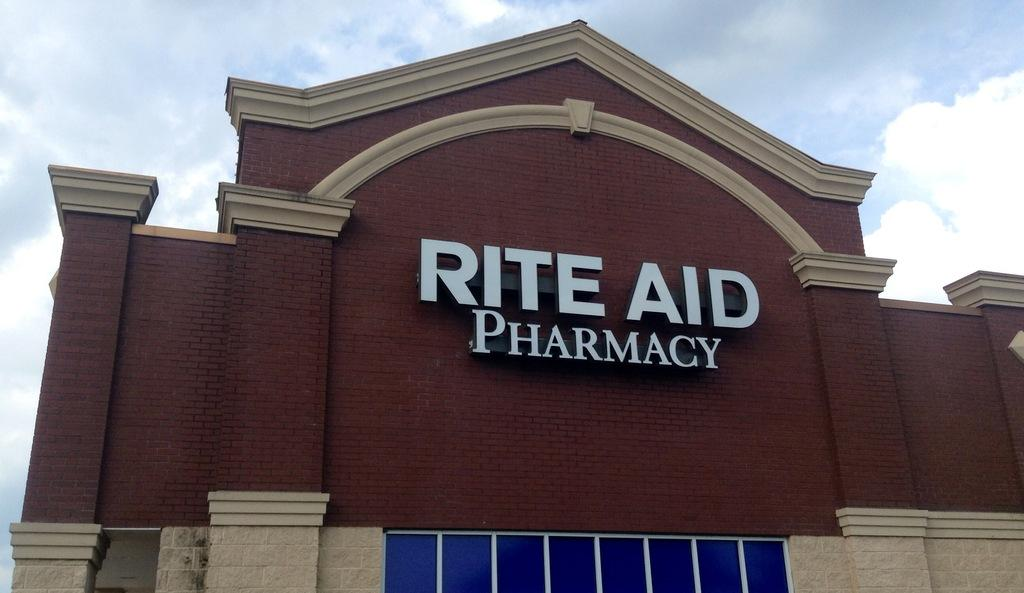What type of structure is in the image? There is a building in the image. What is the name of the building? The name of the building is visible. What is attached to the building? There is a hoarding present on the building. What can be seen in the sky in the image? Clouds are visible in the sky. What time is the wax melting in the image? There is no wax present in the image, so it is not possible to determine when wax might be melting. 